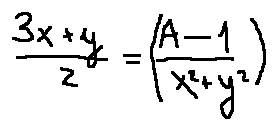Convert formula to latex. <formula><loc_0><loc_0><loc_500><loc_500>\frac { 3 x + y } { z } = ( \frac { A - 1 } { x ^ { 2 } + y ^ { 2 } } )</formula> 